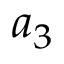<formula> <loc_0><loc_0><loc_500><loc_500>a _ { 3 }</formula> 